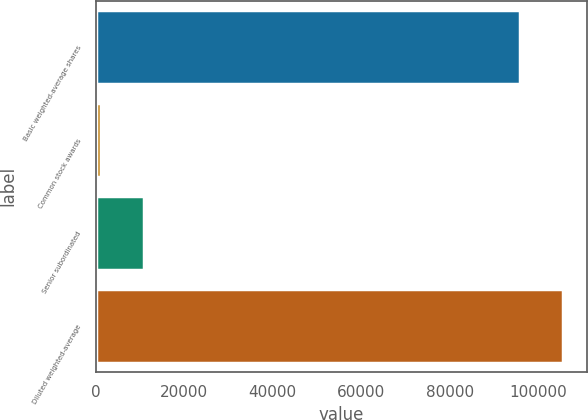<chart> <loc_0><loc_0><loc_500><loc_500><bar_chart><fcel>Basic weighted-average shares<fcel>Common stock awards<fcel>Senior subordinated<fcel>Diluted weighted-average<nl><fcel>95959<fcel>1213<fcel>10930.3<fcel>105676<nl></chart> 